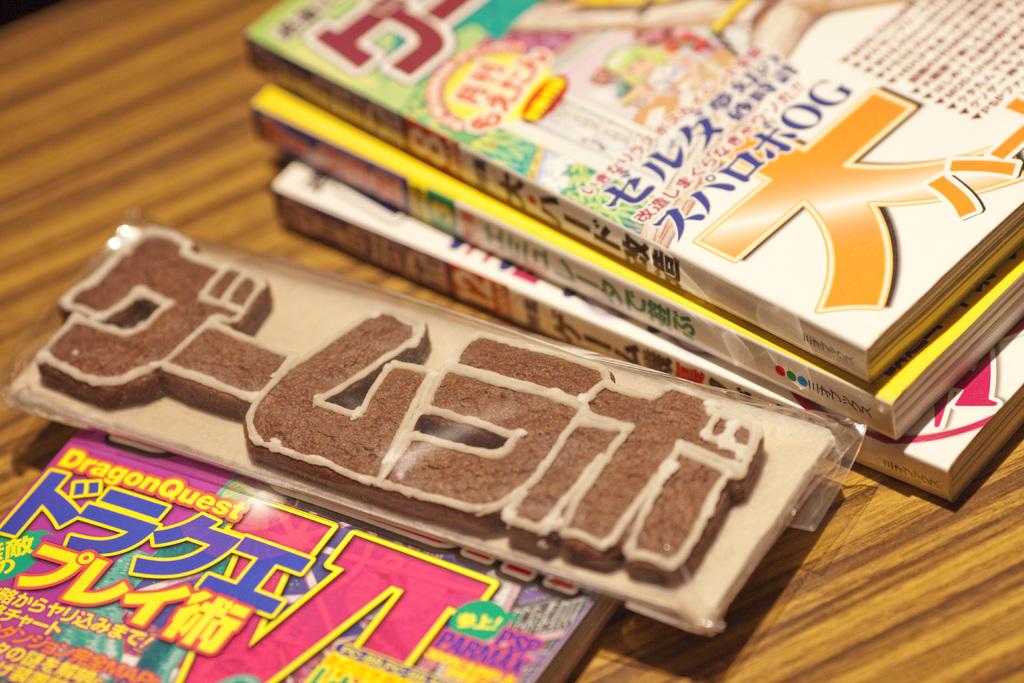What is the name of the pink book?
Your response must be concise. Dragonquest. 